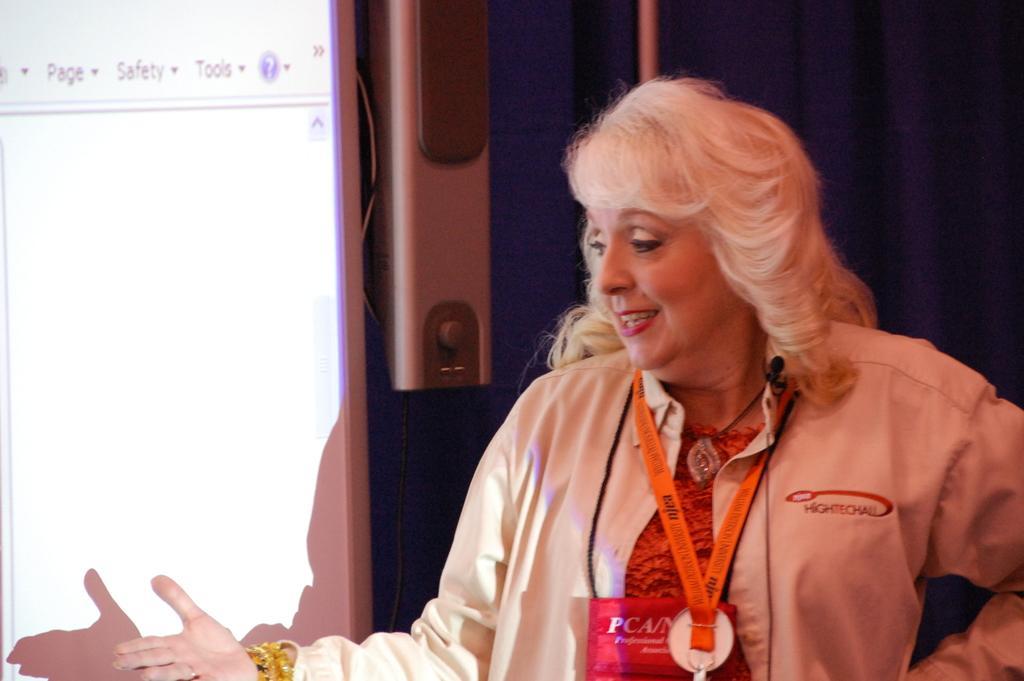Please provide a concise description of this image. In this image I can see the person wearing the dress and identification card. In the background I can see the blue color cloth, speakers and the screen. 